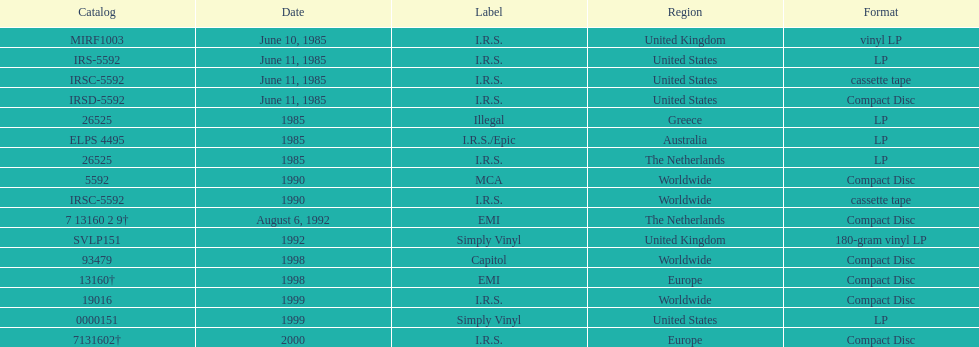How many times was the album released? 13. 